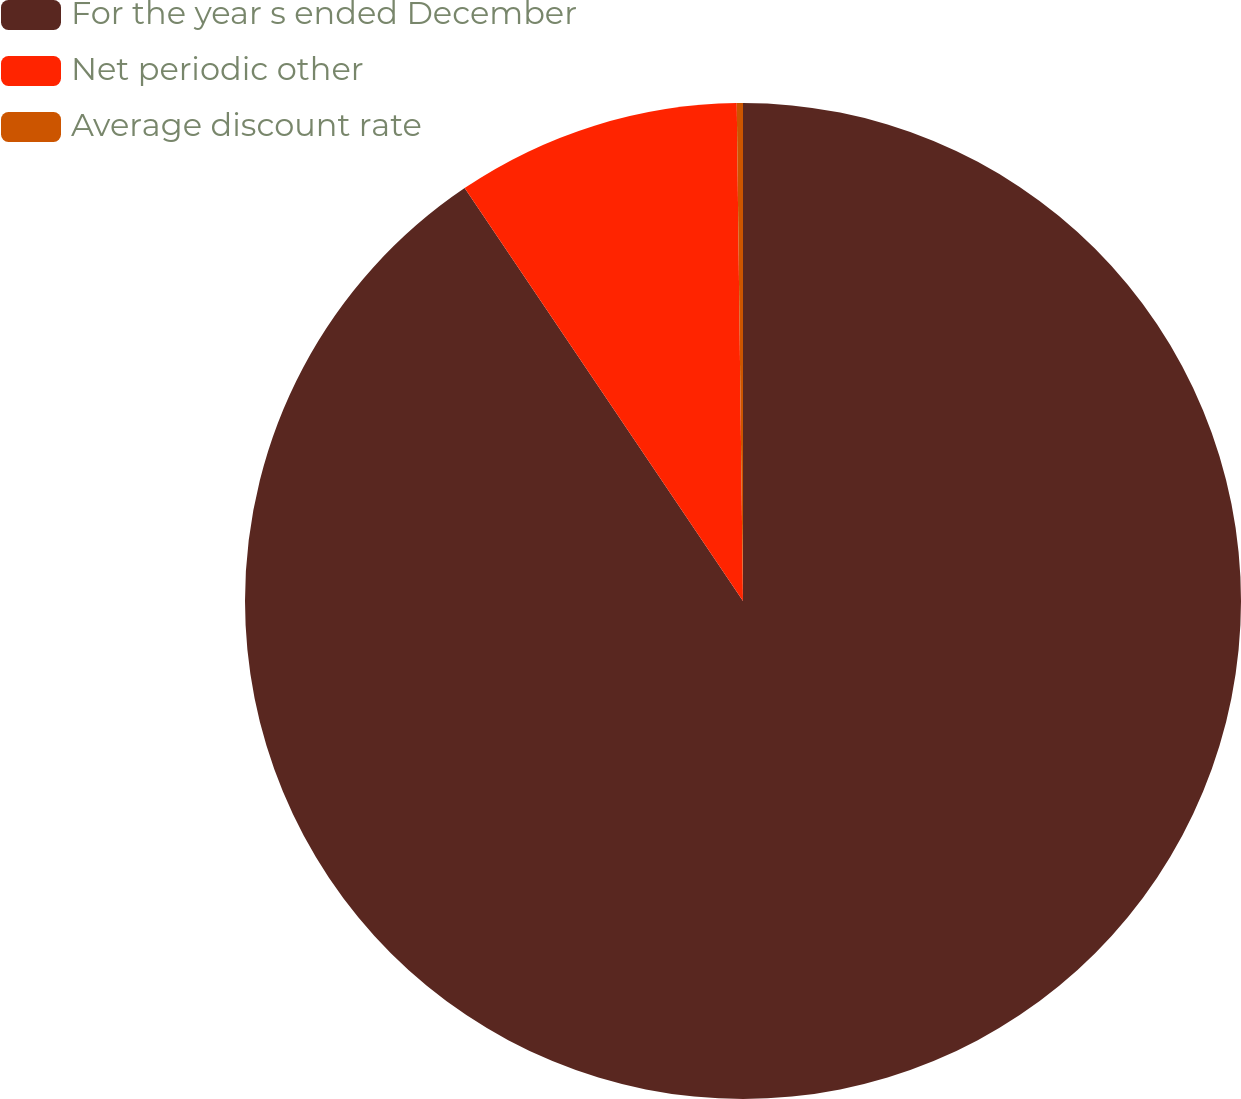Convert chart to OTSL. <chart><loc_0><loc_0><loc_500><loc_500><pie_chart><fcel>For the year s ended December<fcel>Net periodic other<fcel>Average discount rate<nl><fcel>90.56%<fcel>9.24%<fcel>0.2%<nl></chart> 